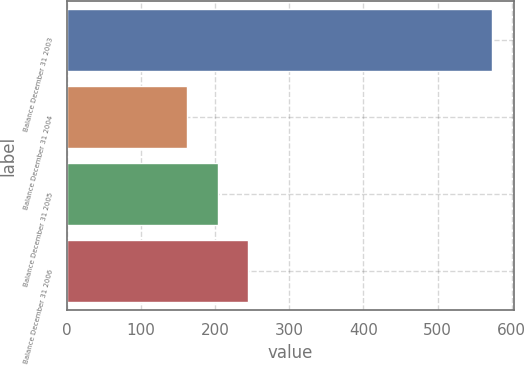Convert chart to OTSL. <chart><loc_0><loc_0><loc_500><loc_500><bar_chart><fcel>Balance December 31 2003<fcel>Balance December 31 2004<fcel>Balance December 31 2005<fcel>Balance December 31 2006<nl><fcel>574<fcel>162<fcel>203.2<fcel>244.4<nl></chart> 